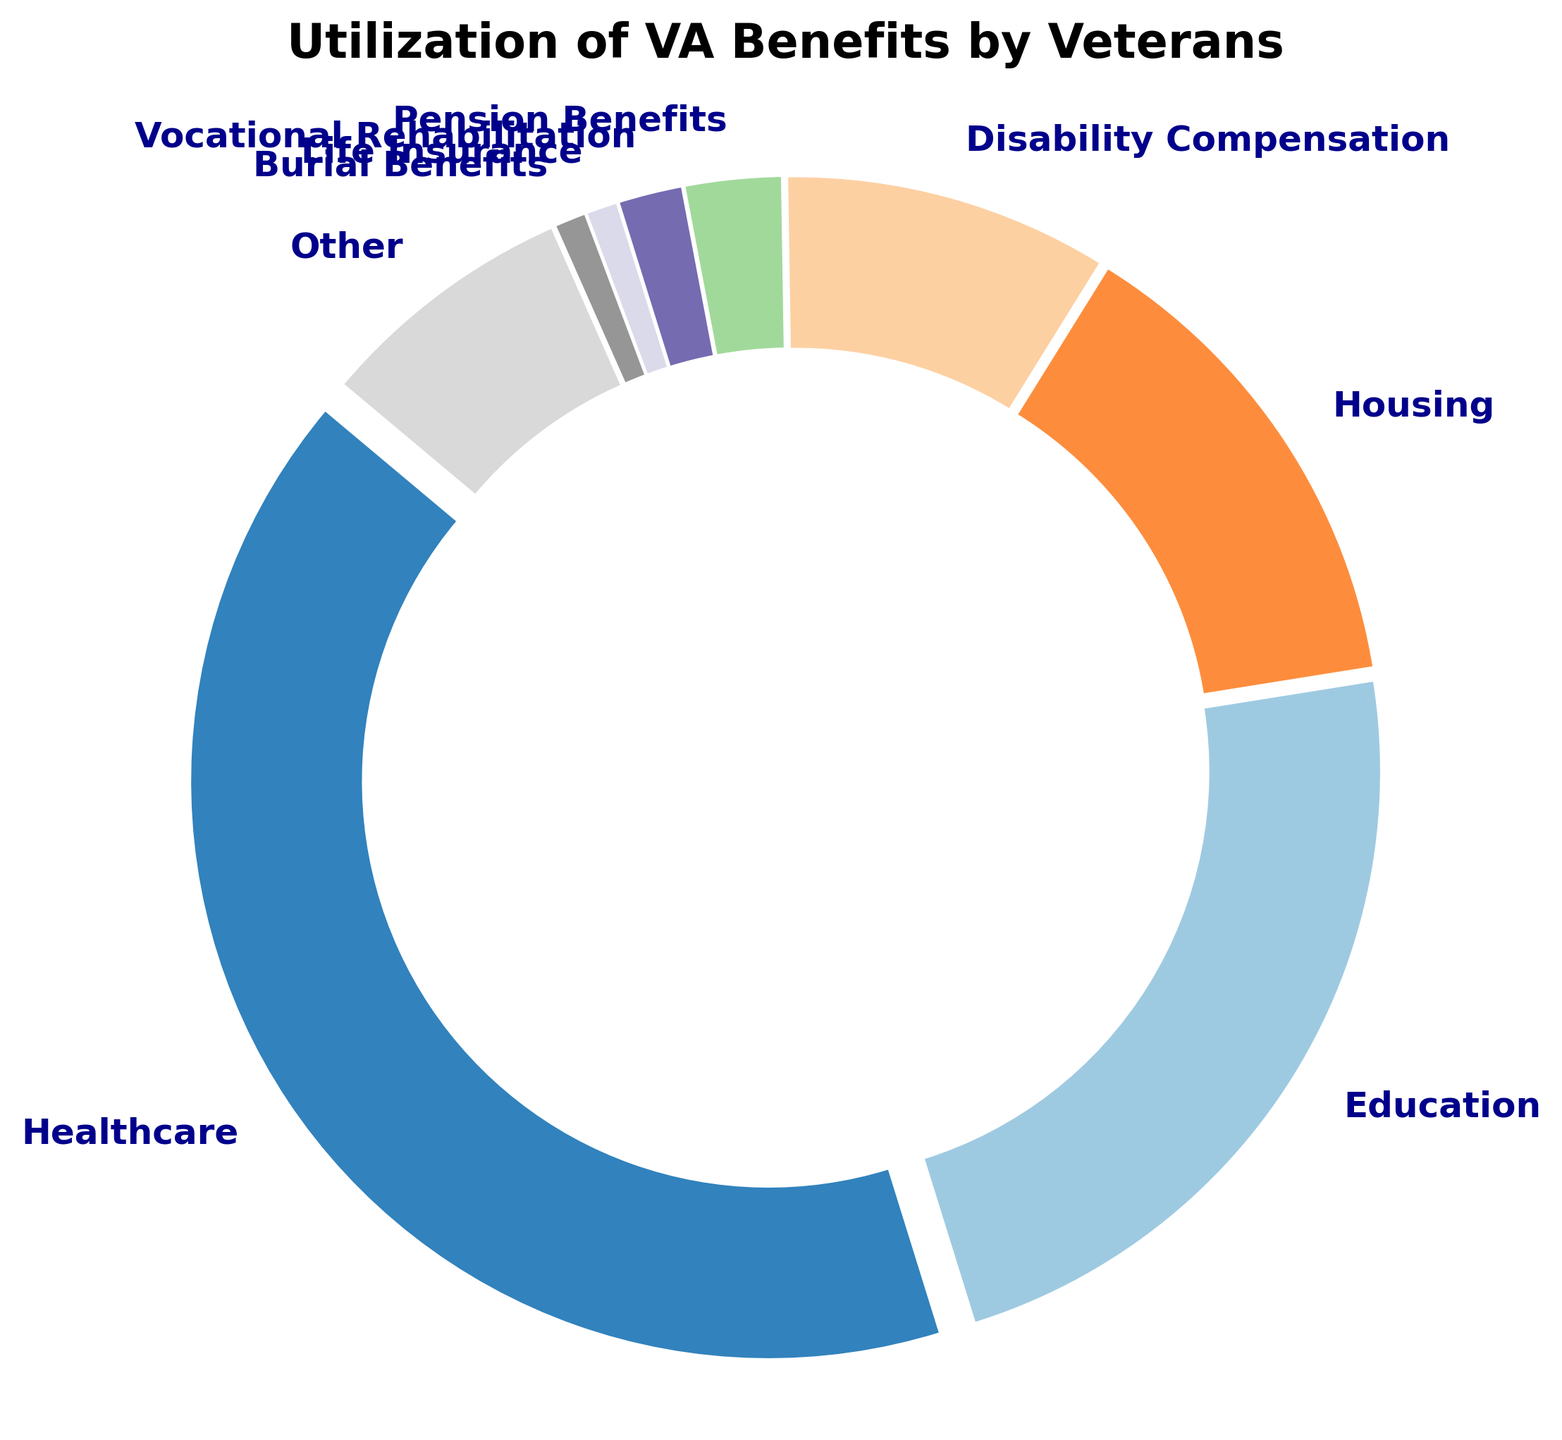Which category of VA benefits has the highest utilization? The ring chart shows that Healthcare is the largest segment in the chart.
Answer: Healthcare What is the combined percentage of Education and Housing benefits? From the chart, Education is 25% and Housing is 15%, so the combined percentage is 25% + 15% = 40%.
Answer: 40% Which two categories of VA benefits have the lowest utilization? The chart indicates that both Life Insurance and Burial Benefits are tied at the lowest percentage, each with 1%.
Answer: Life Insurance and Burial Benefits How much more percentage does Healthcare account for compared to Disability Compensation? Healthcare is 45% and Disability Compensation is 10%, so the difference is 45% - 10% = 35%.
Answer: 35% Is the percentage for Other benefits more or less than the combined percentage for Pension Benefits and Vocational Rehabilitation? Other benefits is 8%, while Pension Benefits and Vocational Rehabilitation combined are 3% + 2% = 5%. 8% > 5%.
Answer: More What color is used for the category with the highest utilization of benefits? By observing the visual attributes of the chart, the largest segment (Healthcare) is predominately colored in light versions of a tab20c palette, often in the starting light shade.
Answer: Light shade (in tab20c color palette) What is the percentage difference between the highest and lowest utilization categories? The highest is Healthcare at 45%, and the lowest are Life Insurance and Burial Benefits at 1%. So, the difference is 45% - 1% = 44%.
Answer: 44% Which category has a larger utilization: Education or Disability Compensation? The chart shows that Education is 25% and Disability Compensation is 10%, so Education has a larger utilization.
Answer: Education Combine the percentages for Vocational Rehabilitation and Life Insurance. How does it compare to Housing? Vocational Rehabilitation is 2% and Life Insurance is 1%, so combined they are 2% + 1% = 3%. Housing is 15%, which is greater.
Answer: Less How much percentage more does Housing benefit accounts for compared to Pension Benefits? Housing is 15% and Pension Benefits is 3%, so the difference is 15% - 3% = 12%.
Answer: 12% 